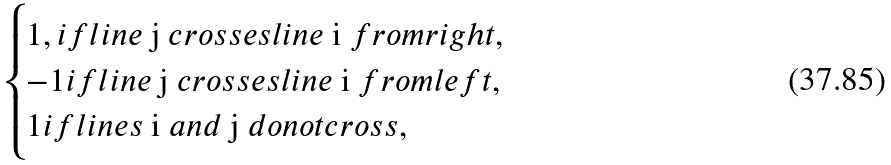Convert formula to latex. <formula><loc_0><loc_0><loc_500><loc_500>\begin{cases} 1 , i f l i n e $ j $ c r o s s e s l i n e $ i $ f r o m r i g h t , \\ - 1 i f l i n e $ j $ c r o s s e s l i n e $ i $ f r o m l e f t , \\ 1 i f l i n e s $ i $ a n d $ j $ d o n o t c r o s s , \end{cases}</formula> 